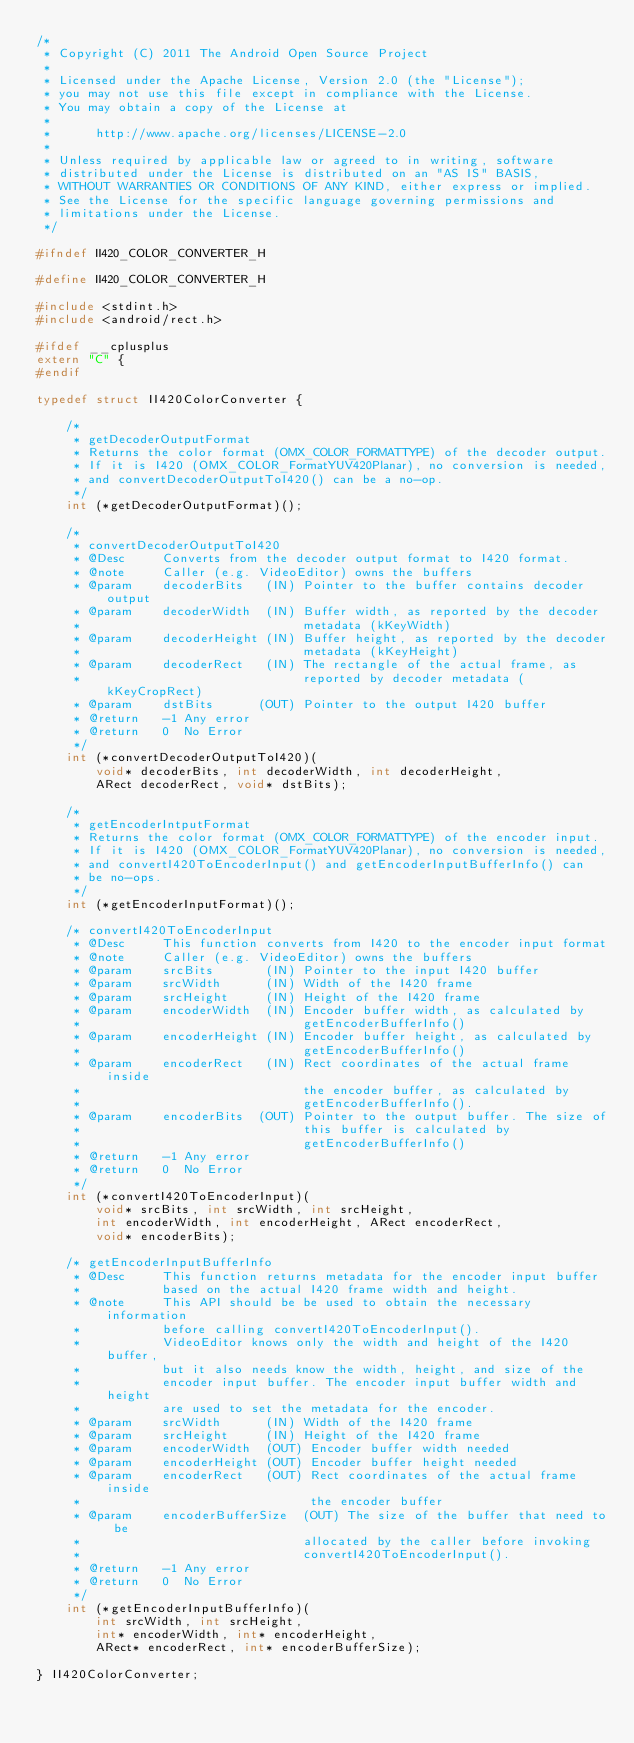Convert code to text. <code><loc_0><loc_0><loc_500><loc_500><_C_>/*
 * Copyright (C) 2011 The Android Open Source Project
 *
 * Licensed under the Apache License, Version 2.0 (the "License");
 * you may not use this file except in compliance with the License.
 * You may obtain a copy of the License at
 *
 *      http://www.apache.org/licenses/LICENSE-2.0
 *
 * Unless required by applicable law or agreed to in writing, software
 * distributed under the License is distributed on an "AS IS" BASIS,
 * WITHOUT WARRANTIES OR CONDITIONS OF ANY KIND, either express or implied.
 * See the License for the specific language governing permissions and
 * limitations under the License.
 */

#ifndef II420_COLOR_CONVERTER_H

#define II420_COLOR_CONVERTER_H

#include <stdint.h>
#include <android/rect.h>

#ifdef __cplusplus
extern "C" {
#endif

typedef struct II420ColorConverter {

    /*
     * getDecoderOutputFormat
     * Returns the color format (OMX_COLOR_FORMATTYPE) of the decoder output.
     * If it is I420 (OMX_COLOR_FormatYUV420Planar), no conversion is needed,
     * and convertDecoderOutputToI420() can be a no-op.
     */
    int (*getDecoderOutputFormat)();

    /*
     * convertDecoderOutputToI420
     * @Desc     Converts from the decoder output format to I420 format.
     * @note     Caller (e.g. VideoEditor) owns the buffers
     * @param    decoderBits   (IN) Pointer to the buffer contains decoder output
     * @param    decoderWidth  (IN) Buffer width, as reported by the decoder
     *                              metadata (kKeyWidth)
     * @param    decoderHeight (IN) Buffer height, as reported by the decoder
     *                              metadata (kKeyHeight)
     * @param    decoderRect   (IN) The rectangle of the actual frame, as
     *                              reported by decoder metadata (kKeyCropRect)
     * @param    dstBits      (OUT) Pointer to the output I420 buffer
     * @return   -1 Any error
     * @return   0  No Error
     */
    int (*convertDecoderOutputToI420)(
        void* decoderBits, int decoderWidth, int decoderHeight,
        ARect decoderRect, void* dstBits);

    /*
     * getEncoderIntputFormat
     * Returns the color format (OMX_COLOR_FORMATTYPE) of the encoder input.
     * If it is I420 (OMX_COLOR_FormatYUV420Planar), no conversion is needed,
     * and convertI420ToEncoderInput() and getEncoderInputBufferInfo() can
     * be no-ops.
     */
    int (*getEncoderInputFormat)();

    /* convertI420ToEncoderInput
     * @Desc     This function converts from I420 to the encoder input format
     * @note     Caller (e.g. VideoEditor) owns the buffers
     * @param    srcBits       (IN) Pointer to the input I420 buffer
     * @param    srcWidth      (IN) Width of the I420 frame
     * @param    srcHeight     (IN) Height of the I420 frame
     * @param    encoderWidth  (IN) Encoder buffer width, as calculated by
     *                              getEncoderBufferInfo()
     * @param    encoderHeight (IN) Encoder buffer height, as calculated by
     *                              getEncoderBufferInfo()
     * @param    encoderRect   (IN) Rect coordinates of the actual frame inside
     *                              the encoder buffer, as calculated by
     *                              getEncoderBufferInfo().
     * @param    encoderBits  (OUT) Pointer to the output buffer. The size of
     *                              this buffer is calculated by
     *                              getEncoderBufferInfo()
     * @return   -1 Any error
     * @return   0  No Error
     */
    int (*convertI420ToEncoderInput)(
        void* srcBits, int srcWidth, int srcHeight,
        int encoderWidth, int encoderHeight, ARect encoderRect,
        void* encoderBits);

    /* getEncoderInputBufferInfo
     * @Desc     This function returns metadata for the encoder input buffer
     *           based on the actual I420 frame width and height.
     * @note     This API should be be used to obtain the necessary information
     *           before calling convertI420ToEncoderInput().
     *           VideoEditor knows only the width and height of the I420 buffer,
     *           but it also needs know the width, height, and size of the
     *           encoder input buffer. The encoder input buffer width and height
     *           are used to set the metadata for the encoder.
     * @param    srcWidth      (IN) Width of the I420 frame
     * @param    srcHeight     (IN) Height of the I420 frame
     * @param    encoderWidth  (OUT) Encoder buffer width needed
     * @param    encoderHeight (OUT) Encoder buffer height needed
     * @param    encoderRect   (OUT) Rect coordinates of the actual frame inside
     *                               the encoder buffer
     * @param    encoderBufferSize  (OUT) The size of the buffer that need to be
     *                              allocated by the caller before invoking
     *                              convertI420ToEncoderInput().
     * @return   -1 Any error
     * @return   0  No Error
     */
    int (*getEncoderInputBufferInfo)(
        int srcWidth, int srcHeight,
        int* encoderWidth, int* encoderHeight,
        ARect* encoderRect, int* encoderBufferSize);

} II420ColorConverter;
</code> 